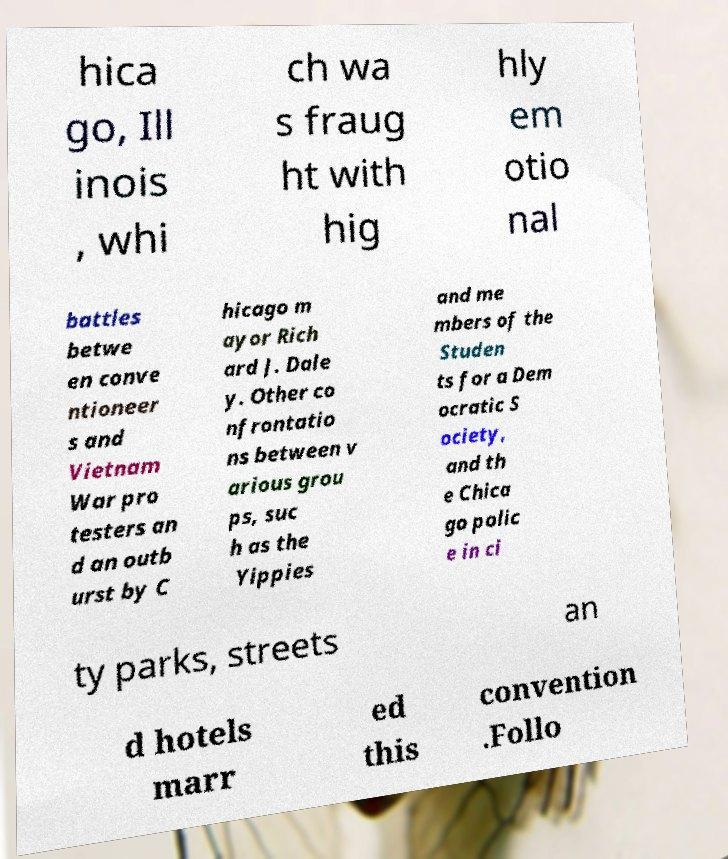I need the written content from this picture converted into text. Can you do that? hica go, Ill inois , whi ch wa s fraug ht with hig hly em otio nal battles betwe en conve ntioneer s and Vietnam War pro testers an d an outb urst by C hicago m ayor Rich ard J. Dale y. Other co nfrontatio ns between v arious grou ps, suc h as the Yippies and me mbers of the Studen ts for a Dem ocratic S ociety, and th e Chica go polic e in ci ty parks, streets an d hotels marr ed this convention .Follo 